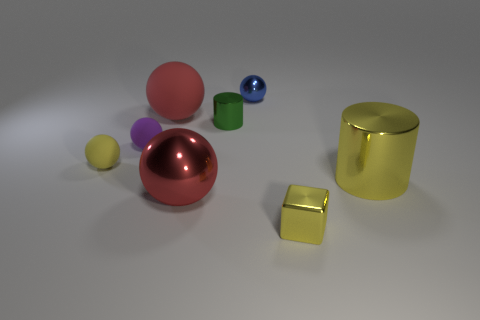What is the shape of the large metallic object left of the blue sphere?
Keep it short and to the point. Sphere. The metal cylinder that is the same color as the block is what size?
Offer a very short reply. Large. Is there a green cylinder of the same size as the blue ball?
Offer a terse response. Yes. Do the tiny cube to the right of the large red rubber sphere and the tiny purple sphere have the same material?
Your answer should be very brief. No. Are there the same number of green metallic cylinders that are on the right side of the big yellow metal cylinder and red spheres that are in front of the tiny yellow sphere?
Offer a very short reply. No. What shape is the small object that is to the left of the red metallic object and behind the tiny yellow rubber thing?
Your answer should be compact. Sphere. How many tiny objects are on the right side of the small yellow rubber object?
Make the answer very short. 4. How many other objects are the same shape as the yellow rubber object?
Your answer should be very brief. 4. Are there fewer small green cubes than small balls?
Offer a very short reply. Yes. There is a rubber object that is in front of the green cylinder and on the right side of the yellow matte thing; what is its size?
Offer a terse response. Small. 